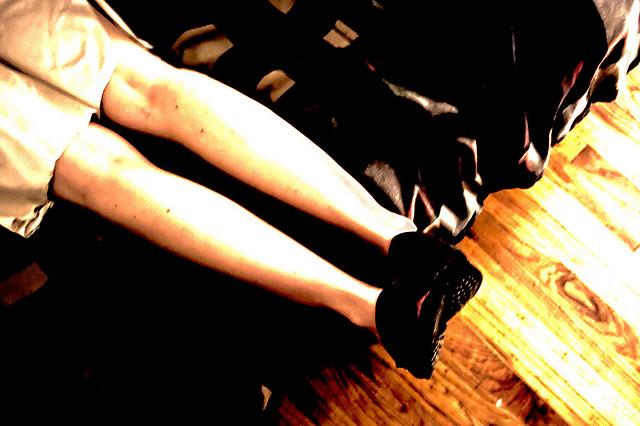What is on the feet?
Quick response, please. Shoes. How many people are there?
Be succinct. 1. Is that carpet on the ground?
Concise answer only. No. 